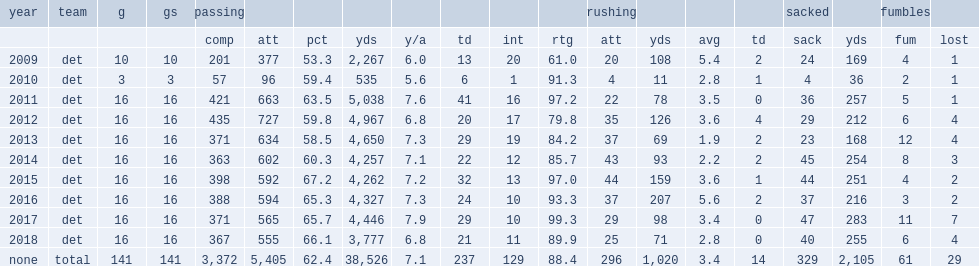Parse the table in full. {'header': ['year', 'team', 'g', 'gs', 'passing', '', '', '', '', '', '', '', 'rushing', '', '', '', 'sacked', '', 'fumbles', ''], 'rows': [['', '', '', '', 'comp', 'att', 'pct', 'yds', 'y/a', 'td', 'int', 'rtg', 'att', 'yds', 'avg', 'td', 'sack', 'yds', 'fum', 'lost'], ['2009', 'det', '10', '10', '201', '377', '53.3', '2,267', '6.0', '13', '20', '61.0', '20', '108', '5.4', '2', '24', '169', '4', '1'], ['2010', 'det', '3', '3', '57', '96', '59.4', '535', '5.6', '6', '1', '91.3', '4', '11', '2.8', '1', '4', '36', '2', '1'], ['2011', 'det', '16', '16', '421', '663', '63.5', '5,038', '7.6', '41', '16', '97.2', '22', '78', '3.5', '0', '36', '257', '5', '1'], ['2012', 'det', '16', '16', '435', '727', '59.8', '4,967', '6.8', '20', '17', '79.8', '35', '126', '3.6', '4', '29', '212', '6', '4'], ['2013', 'det', '16', '16', '371', '634', '58.5', '4,650', '7.3', '29', '19', '84.2', '37', '69', '1.9', '2', '23', '168', '12', '4'], ['2014', 'det', '16', '16', '363', '602', '60.3', '4,257', '7.1', '22', '12', '85.7', '43', '93', '2.2', '2', '45', '254', '8', '3'], ['2015', 'det', '16', '16', '398', '592', '67.2', '4,262', '7.2', '32', '13', '97.0', '44', '159', '3.6', '1', '44', '251', '4', '2'], ['2016', 'det', '16', '16', '388', '594', '65.3', '4,327', '7.3', '24', '10', '93.3', '37', '207', '5.6', '2', '37', '216', '3', '2'], ['2017', 'det', '16', '16', '371', '565', '65.7', '4,446', '7.9', '29', '10', '99.3', '29', '98', '3.4', '0', '47', '283', '11', '7'], ['2018', 'det', '16', '16', '367', '555', '66.1', '3,777', '6.8', '21', '11', '89.9', '25', '71', '2.8', '0', '40', '255', '6', '4'], ['none', 'total', '141', '141', '3,372', '5,405', '62.4', '38,526', '7.1', '237', '129', '88.4', '296', '1,020', '3.4', '14', '329', '2,105', '61', '29']]} How many passing yards did stafford get in 2014? 4257.0. 